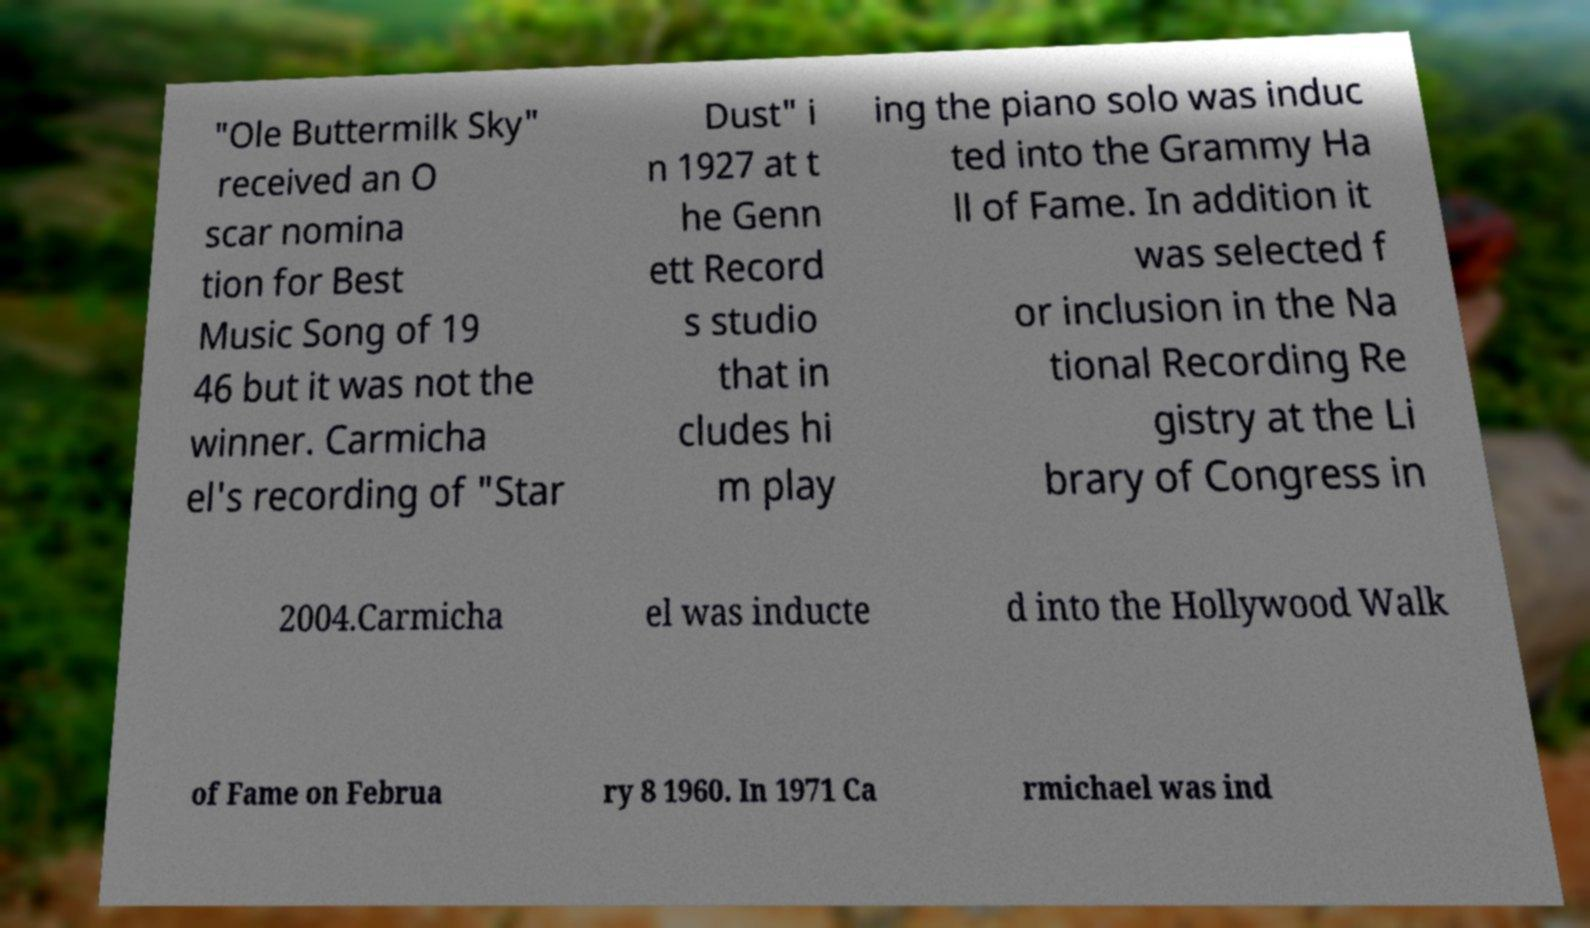Could you assist in decoding the text presented in this image and type it out clearly? "Ole Buttermilk Sky" received an O scar nomina tion for Best Music Song of 19 46 but it was not the winner. Carmicha el's recording of "Star Dust" i n 1927 at t he Genn ett Record s studio that in cludes hi m play ing the piano solo was induc ted into the Grammy Ha ll of Fame. In addition it was selected f or inclusion in the Na tional Recording Re gistry at the Li brary of Congress in 2004.Carmicha el was inducte d into the Hollywood Walk of Fame on Februa ry 8 1960. In 1971 Ca rmichael was ind 